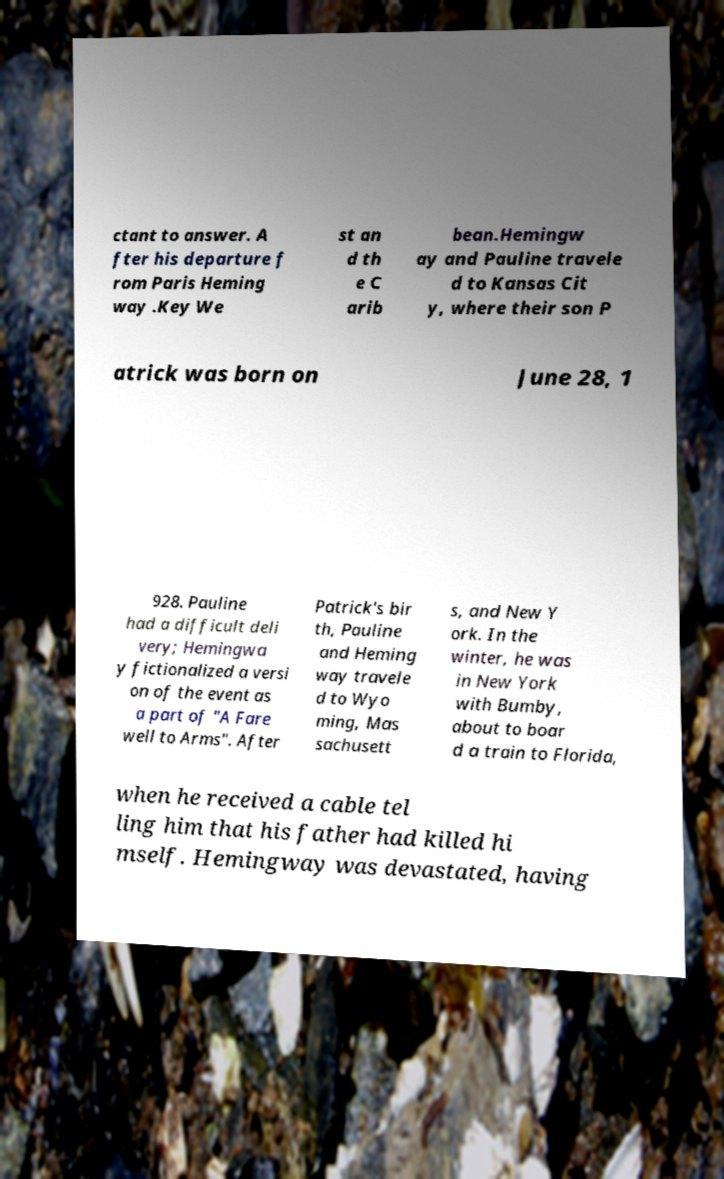Can you read and provide the text displayed in the image?This photo seems to have some interesting text. Can you extract and type it out for me? ctant to answer. A fter his departure f rom Paris Heming way .Key We st an d th e C arib bean.Hemingw ay and Pauline travele d to Kansas Cit y, where their son P atrick was born on June 28, 1 928. Pauline had a difficult deli very; Hemingwa y fictionalized a versi on of the event as a part of "A Fare well to Arms". After Patrick's bir th, Pauline and Heming way travele d to Wyo ming, Mas sachusett s, and New Y ork. In the winter, he was in New York with Bumby, about to boar d a train to Florida, when he received a cable tel ling him that his father had killed hi mself. Hemingway was devastated, having 